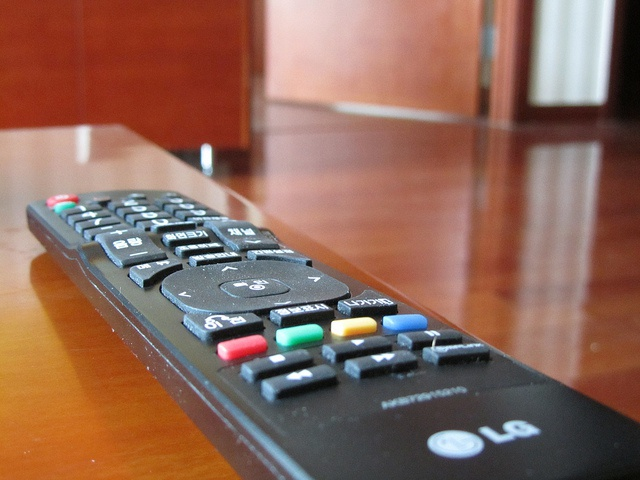Describe the objects in this image and their specific colors. I can see a remote in brown, gray, black, and darkgray tones in this image. 